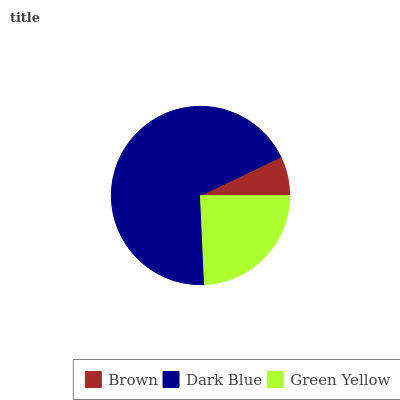Is Brown the minimum?
Answer yes or no. Yes. Is Dark Blue the maximum?
Answer yes or no. Yes. Is Green Yellow the minimum?
Answer yes or no. No. Is Green Yellow the maximum?
Answer yes or no. No. Is Dark Blue greater than Green Yellow?
Answer yes or no. Yes. Is Green Yellow less than Dark Blue?
Answer yes or no. Yes. Is Green Yellow greater than Dark Blue?
Answer yes or no. No. Is Dark Blue less than Green Yellow?
Answer yes or no. No. Is Green Yellow the high median?
Answer yes or no. Yes. Is Green Yellow the low median?
Answer yes or no. Yes. Is Brown the high median?
Answer yes or no. No. Is Dark Blue the low median?
Answer yes or no. No. 